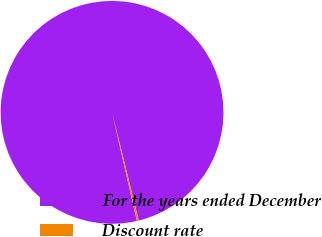Convert chart to OTSL. <chart><loc_0><loc_0><loc_500><loc_500><pie_chart><fcel>For the years ended December<fcel>Discount rate<nl><fcel>99.73%<fcel>0.27%<nl></chart> 